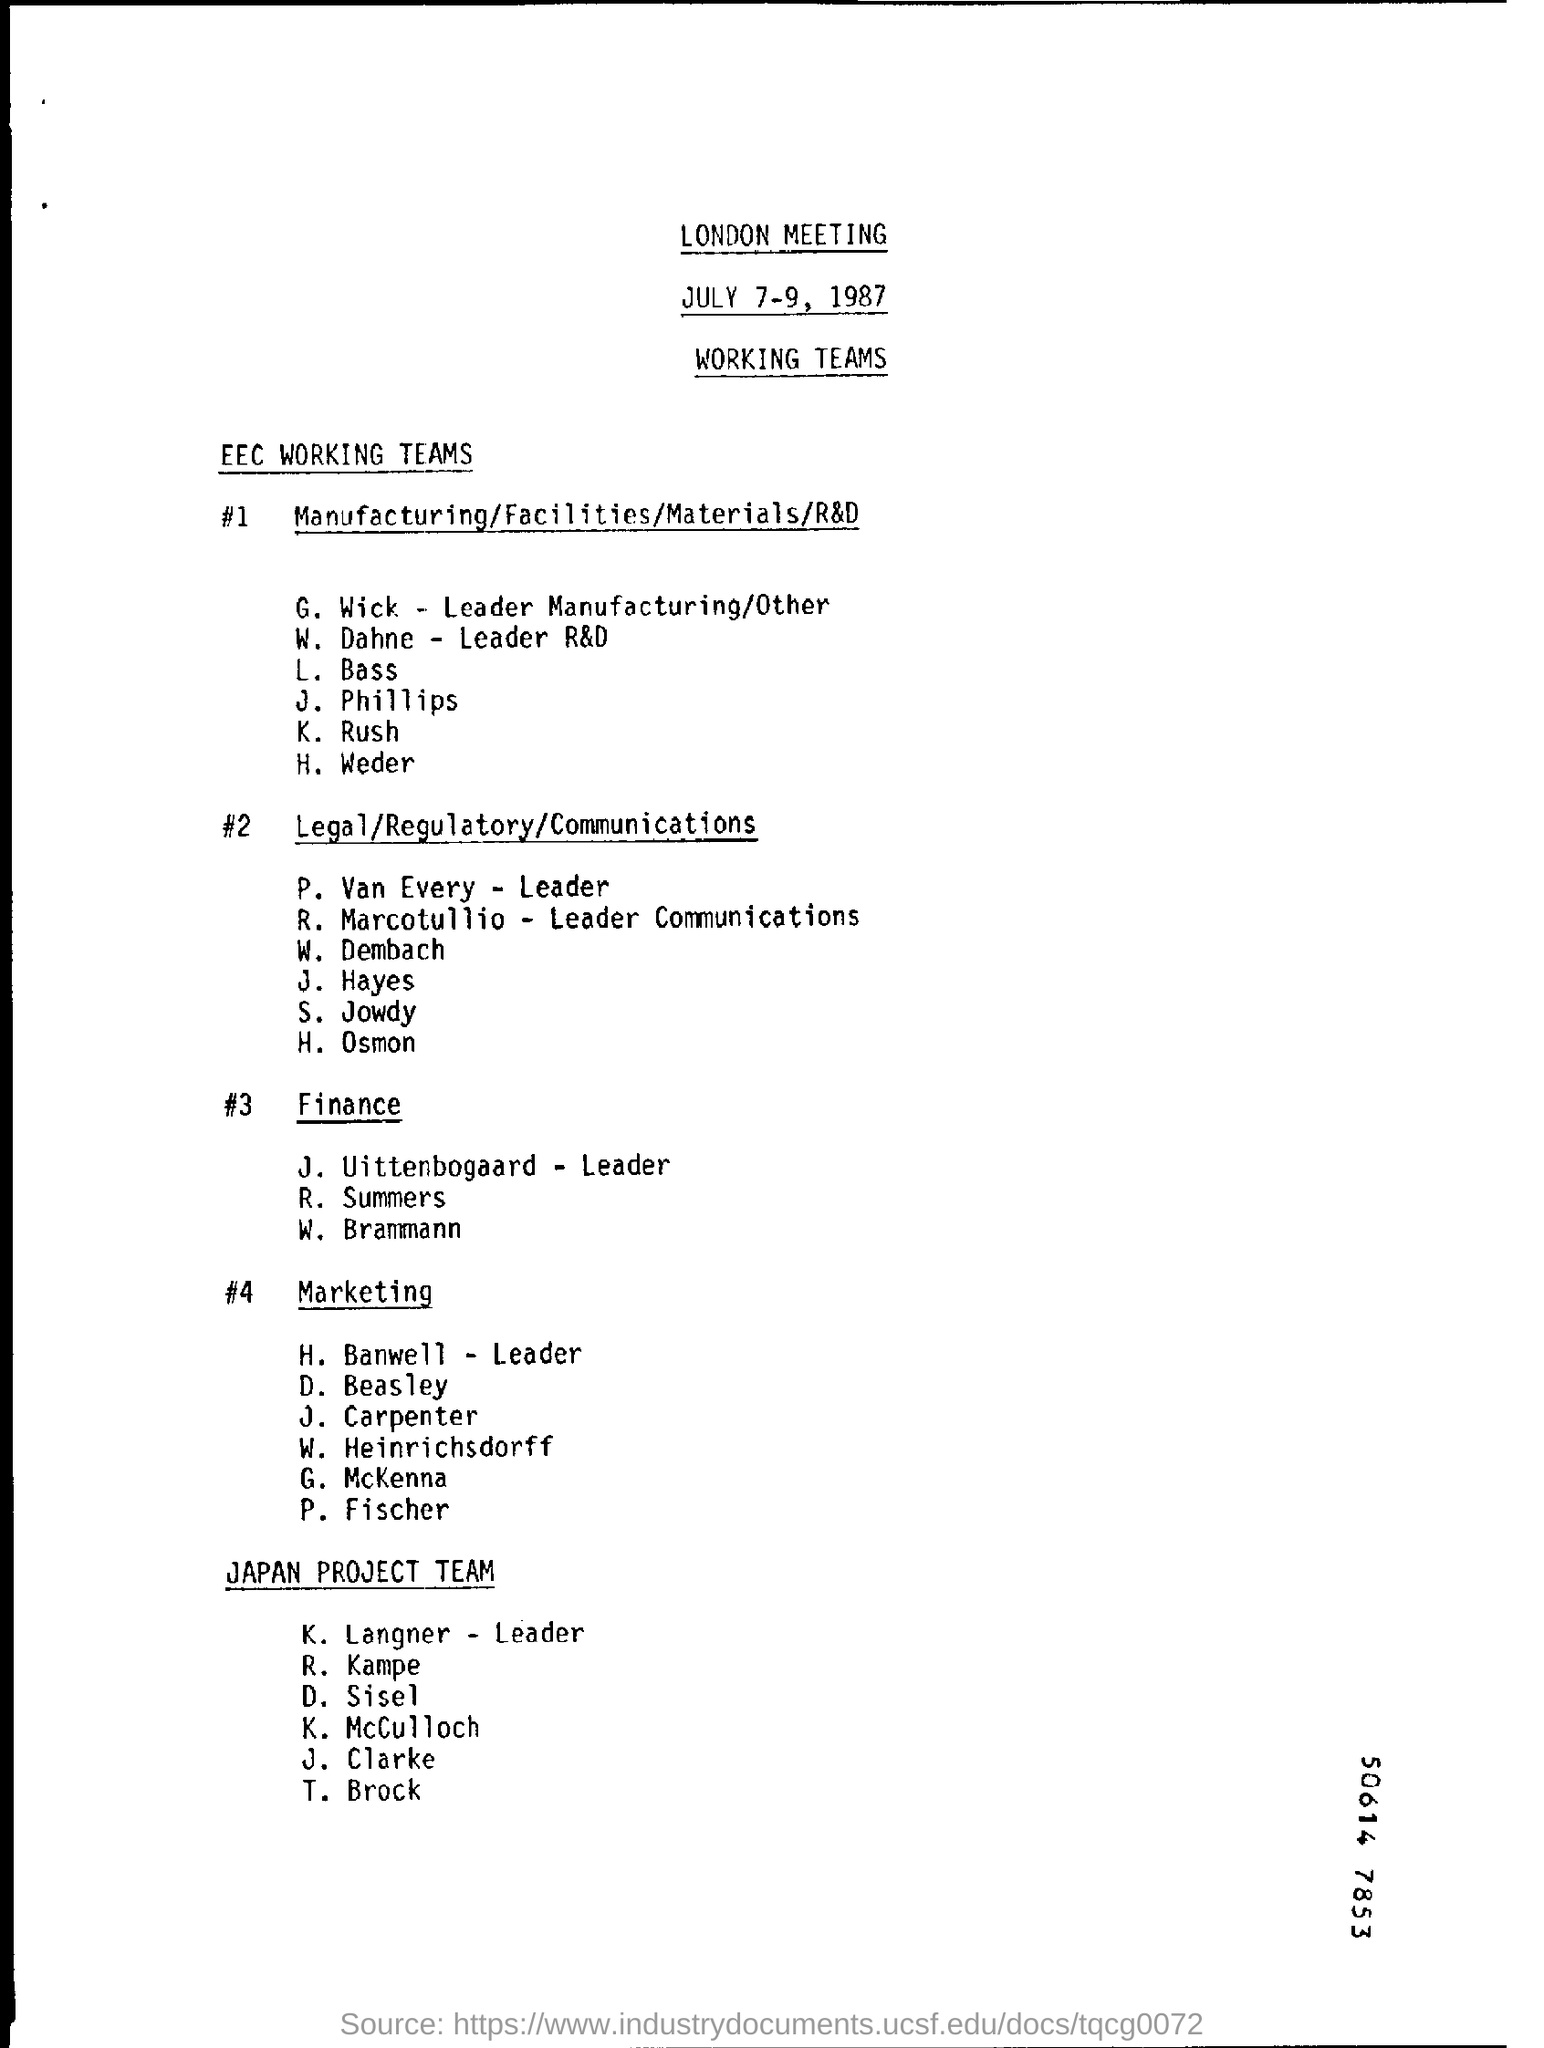What is the Title of the document ?
Ensure brevity in your answer.  LONDON MEETING. What is the date mentioned in the top of the document ?
Provide a short and direct response. JULY 7-9, 1987. 